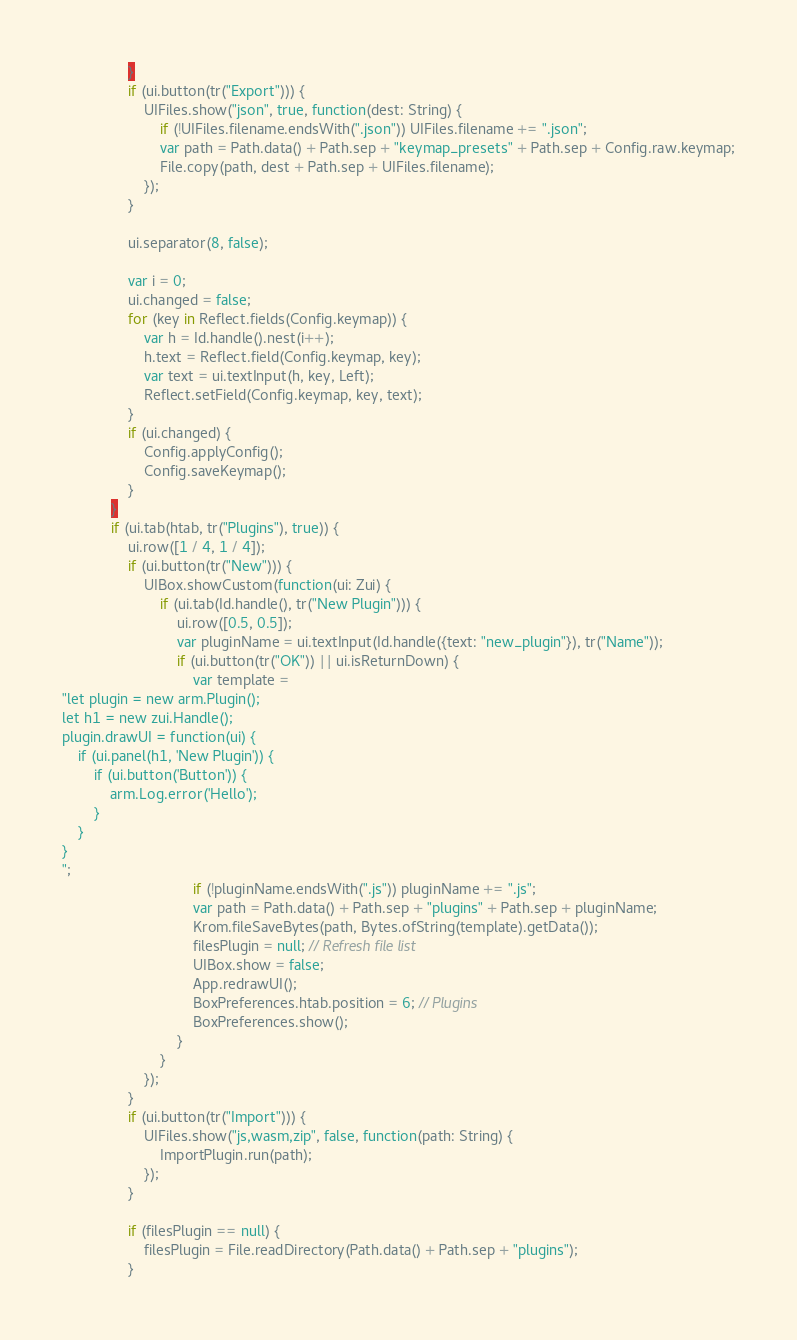<code> <loc_0><loc_0><loc_500><loc_500><_Haxe_>				}
				if (ui.button(tr("Export"))) {
					UIFiles.show("json", true, function(dest: String) {
						if (!UIFiles.filename.endsWith(".json")) UIFiles.filename += ".json";
						var path = Path.data() + Path.sep + "keymap_presets" + Path.sep + Config.raw.keymap;
						File.copy(path, dest + Path.sep + UIFiles.filename);
					});
				}

				ui.separator(8, false);

				var i = 0;
				ui.changed = false;
				for (key in Reflect.fields(Config.keymap)) {
					var h = Id.handle().nest(i++);
					h.text = Reflect.field(Config.keymap, key);
					var text = ui.textInput(h, key, Left);
					Reflect.setField(Config.keymap, key, text);
				}
				if (ui.changed) {
					Config.applyConfig();
					Config.saveKeymap();
				}
			}
			if (ui.tab(htab, tr("Plugins"), true)) {
				ui.row([1 / 4, 1 / 4]);
				if (ui.button(tr("New"))) {
					UIBox.showCustom(function(ui: Zui) {
						if (ui.tab(Id.handle(), tr("New Plugin"))) {
							ui.row([0.5, 0.5]);
							var pluginName = ui.textInput(Id.handle({text: "new_plugin"}), tr("Name"));
							if (ui.button(tr("OK")) || ui.isReturnDown) {
								var template =
"let plugin = new arm.Plugin();
let h1 = new zui.Handle();
plugin.drawUI = function(ui) {
	if (ui.panel(h1, 'New Plugin')) {
		if (ui.button('Button')) {
			arm.Log.error('Hello');
		}
	}
}
";
								if (!pluginName.endsWith(".js")) pluginName += ".js";
								var path = Path.data() + Path.sep + "plugins" + Path.sep + pluginName;
								Krom.fileSaveBytes(path, Bytes.ofString(template).getData());
								filesPlugin = null; // Refresh file list
								UIBox.show = false;
								App.redrawUI();
								BoxPreferences.htab.position = 6; // Plugins
								BoxPreferences.show();
							}
						}
					});
				}
				if (ui.button(tr("Import"))) {
					UIFiles.show("js,wasm,zip", false, function(path: String) {
						ImportPlugin.run(path);
					});
				}

				if (filesPlugin == null) {
					filesPlugin = File.readDirectory(Path.data() + Path.sep + "plugins");
				}
</code> 